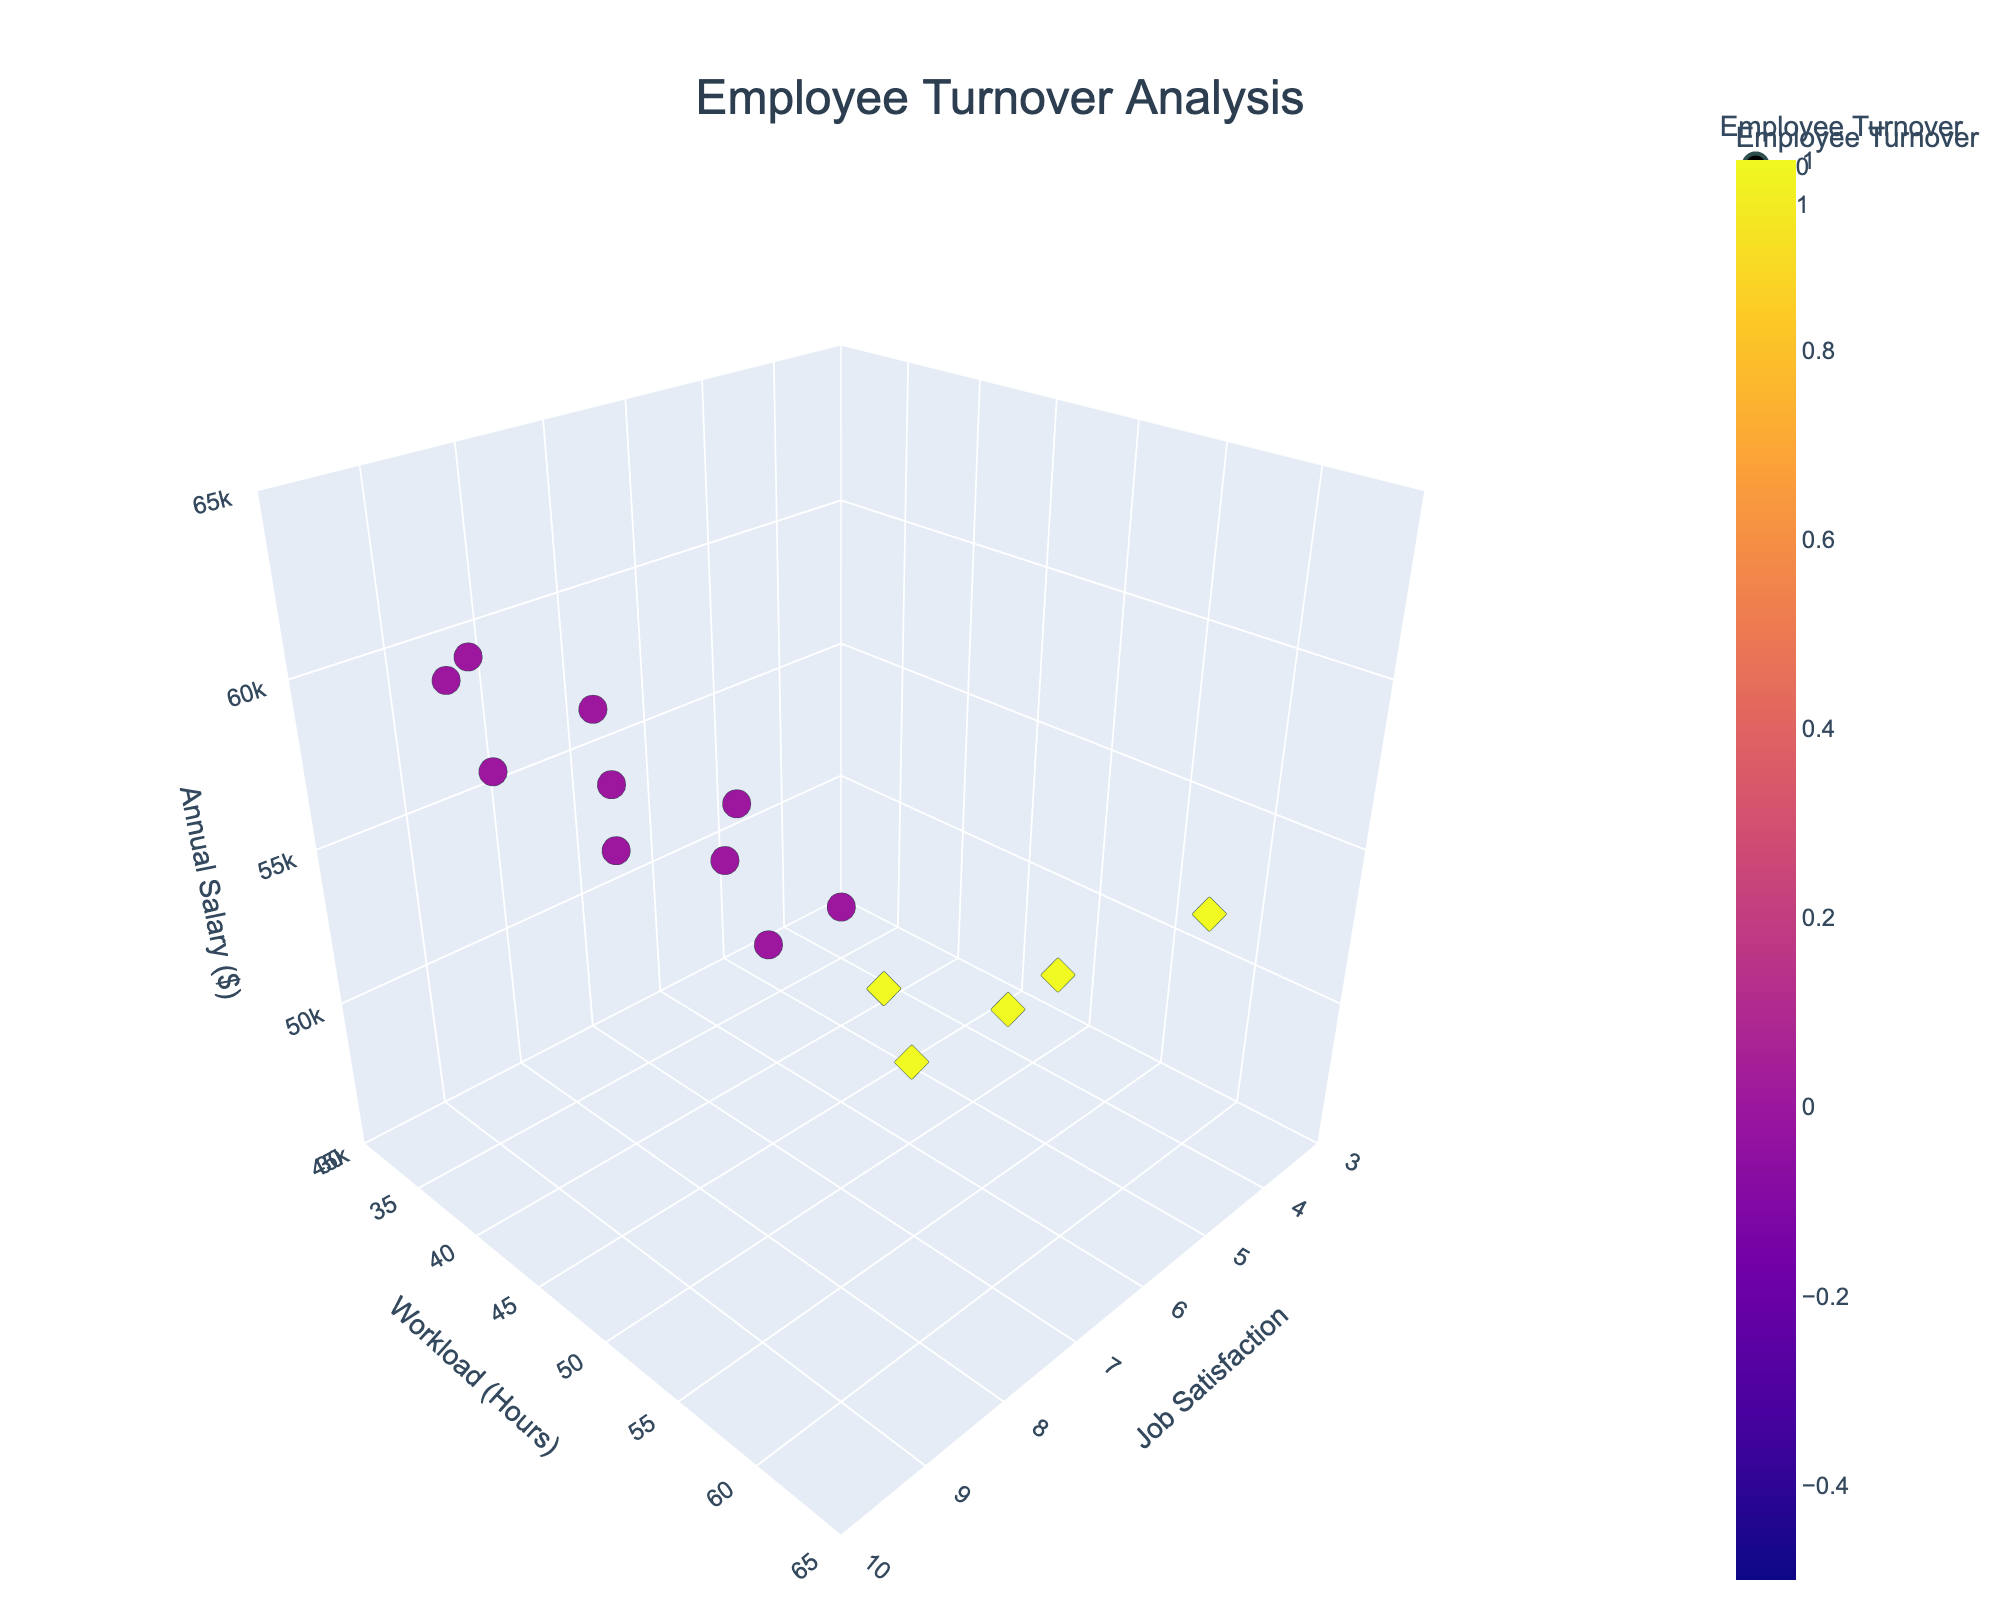What is the title of the plot? The title text appears at the top center of the plot and reads "Employee Turnover Analysis."
Answer: Employee Turnover Analysis How many data points on the plot represent employees who did not turnover? The plot uses different colors and symbols to represent employees who did and did not turnover. By looking at the color key, we can count the number of blue markers (employees who did not turnover).
Answer: 10 What is the range of annual salary shown in the plot? The z-axis is labeled "Annual Salary ($)" and has tick marks. Observing the range defined on this axis allows us to determine the minimum and maximum salary values displayed.
Answer: $45,000 to $65,000 What is the relationship between workload hours and turnover rates? By observing the workload hours on the y-axis and cross-referencing this with the color and symbol indicating turnover, we can describe the trend. Generally, employees with higher workload hours appear to have higher turnover.
Answer: Higher workload, higher turnover Which employees have the highest job satisfaction and did not turnover? We look for the data points with the highest x-values (Job Satisfaction) and check the color and symbol to ensure these are the ones indicating no turnover. We find "Emily Chen," "Christopher Martinez," and "James Harris" have job satisfaction ratings of 9 and did not turnover.
Answer: Emily Chen, Christopher Martinez, James Harris What is the job satisfaction level of David Brown and Amanda Garcia? Locate the data points by their names using hover information or labels, and note the x-axis values for Job Satisfaction.
Answer: David: 5, Amanda: 6 What is the average workload hours for employees who turned over? We need to identify the workload hours for all employees who turned over (symbol and color for turnover) and compute their mean. The employees are Michael Lee, David Brown, Amanda Garcia, Lisa Anderson, and Daniel White, with workload hours of 50, 55, 48, 60, and 52 respectively. (50 + 55 + 48 + 60 + 52) / 5 = 265 / 5 = 53
Answer: 53 Is there any employee who has a job satisfaction level of 4? Scan the x-axis for a job satisfaction value of 4. Observe the markers to check if any hover information matches this level. Lisa Anderson has a job satisfaction of 4.
Answer: Yes, Lisa Anderson Do employees with higher salaries tend to stay with the company? By observing the z-axis (Annual Salary) and correlating with turnover markers (color and symbol), we can infer whether a trend exists. Generally, higher salaries are mostly associated with non-turnover employees.
Answer: Yes Which employee has a workload of 37 hours and did not turnover? Locate the point on the y-axis corresponding to 37 hours of workload and check for turnover status (no turnover). The result shows James Harris.
Answer: James Harris 